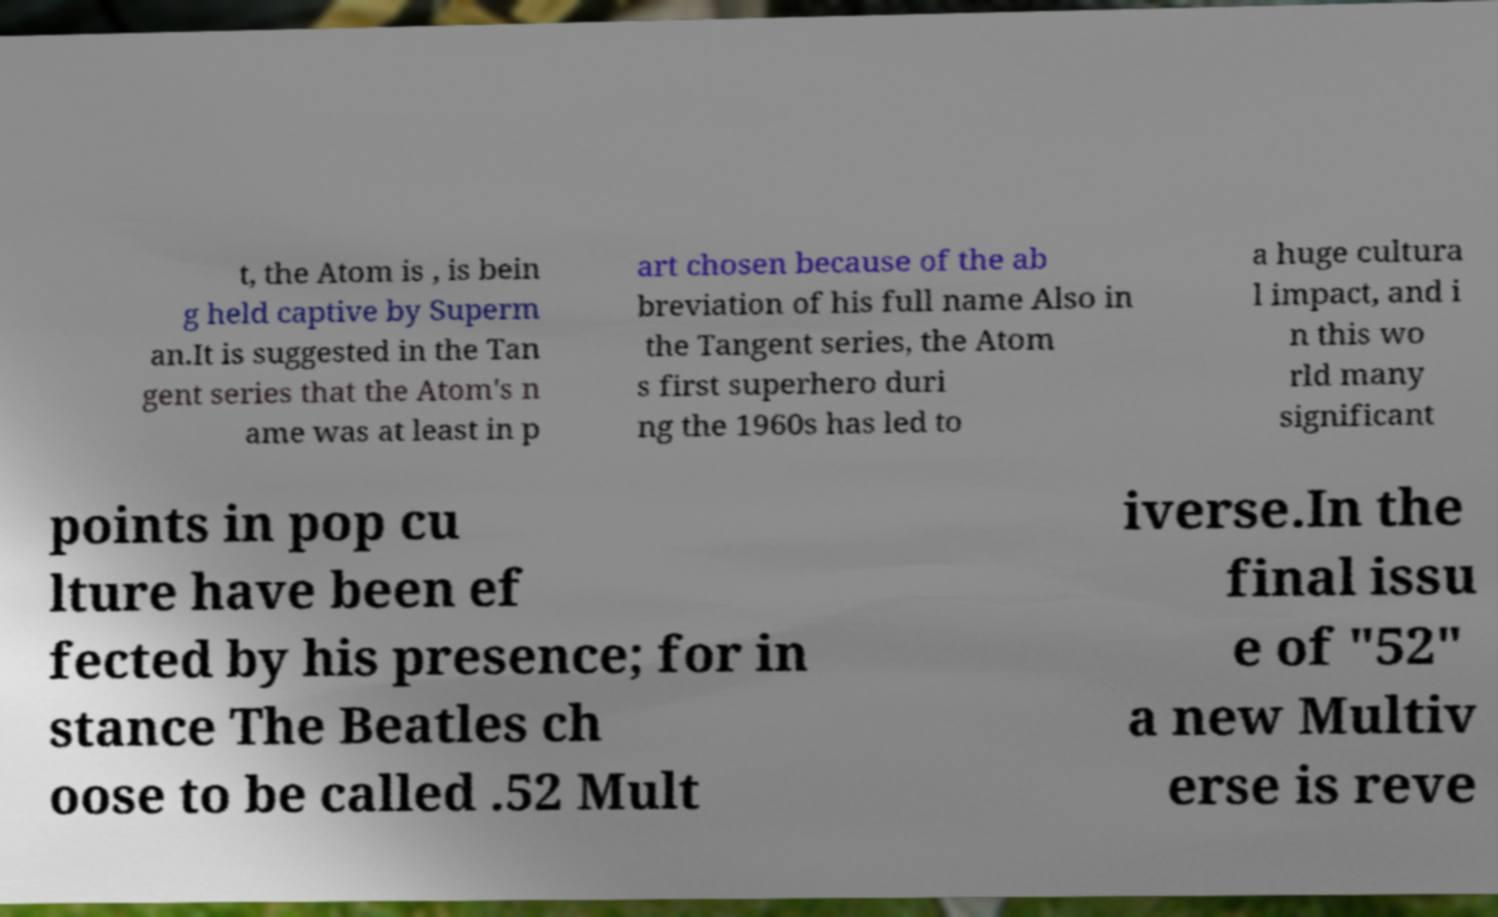Please read and relay the text visible in this image. What does it say? t, the Atom is , is bein g held captive by Superm an.It is suggested in the Tan gent series that the Atom's n ame was at least in p art chosen because of the ab breviation of his full name Also in the Tangent series, the Atom s first superhero duri ng the 1960s has led to a huge cultura l impact, and i n this wo rld many significant points in pop cu lture have been ef fected by his presence; for in stance The Beatles ch oose to be called .52 Mult iverse.In the final issu e of "52" a new Multiv erse is reve 